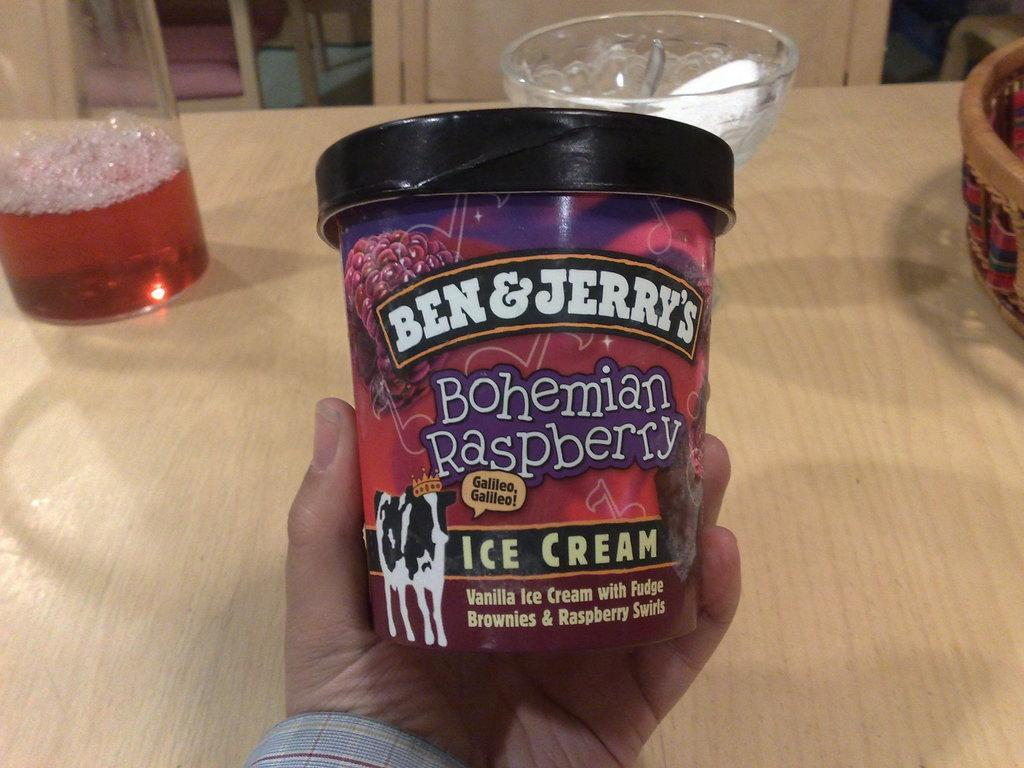In one or two sentences, can you explain what this image depicts? In this image we can see a person's hand holding a packed ice cream and there is a glass of drink, bowl and some other object on the table, in front of the table there are chairs. 